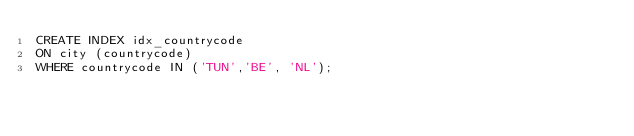Convert code to text. <code><loc_0><loc_0><loc_500><loc_500><_SQL_>CREATE INDEX idx_countrycode
ON city (countrycode)
WHERE countrycode IN ('TUN','BE', 'NL');</code> 